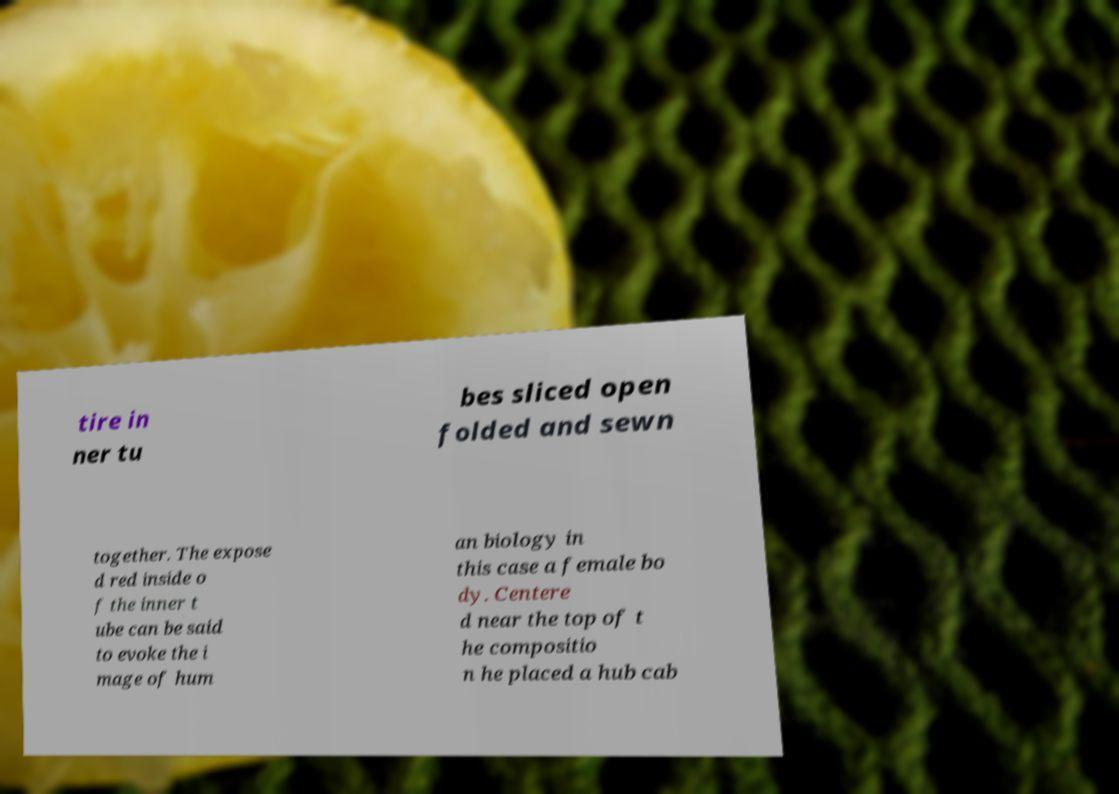What messages or text are displayed in this image? I need them in a readable, typed format. tire in ner tu bes sliced open folded and sewn together. The expose d red inside o f the inner t ube can be said to evoke the i mage of hum an biology in this case a female bo dy. Centere d near the top of t he compositio n he placed a hub cab 